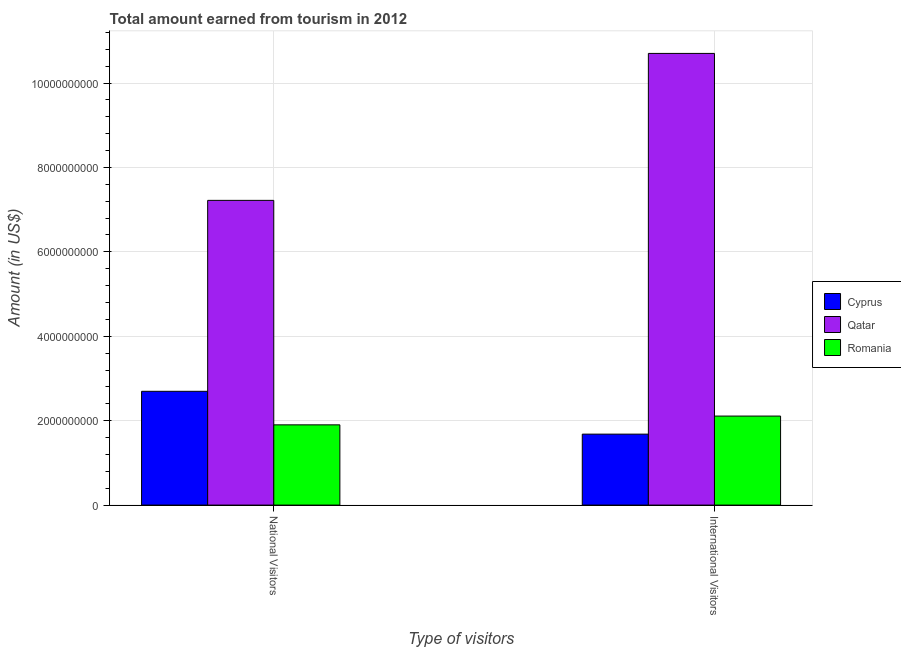How many groups of bars are there?
Your answer should be compact. 2. Are the number of bars on each tick of the X-axis equal?
Your response must be concise. Yes. How many bars are there on the 1st tick from the left?
Keep it short and to the point. 3. How many bars are there on the 2nd tick from the right?
Provide a short and direct response. 3. What is the label of the 1st group of bars from the left?
Give a very brief answer. National Visitors. What is the amount earned from international visitors in Qatar?
Offer a very short reply. 1.07e+1. Across all countries, what is the maximum amount earned from national visitors?
Give a very brief answer. 7.22e+09. Across all countries, what is the minimum amount earned from national visitors?
Your answer should be very brief. 1.90e+09. In which country was the amount earned from international visitors maximum?
Offer a very short reply. Qatar. In which country was the amount earned from national visitors minimum?
Offer a terse response. Romania. What is the total amount earned from national visitors in the graph?
Your response must be concise. 1.18e+1. What is the difference between the amount earned from national visitors in Cyprus and that in Qatar?
Provide a succinct answer. -4.52e+09. What is the difference between the amount earned from international visitors in Qatar and the amount earned from national visitors in Cyprus?
Your answer should be very brief. 8.01e+09. What is the average amount earned from international visitors per country?
Give a very brief answer. 4.83e+09. What is the difference between the amount earned from international visitors and amount earned from national visitors in Romania?
Provide a succinct answer. 2.08e+08. In how many countries, is the amount earned from international visitors greater than 8400000000 US$?
Keep it short and to the point. 1. What is the ratio of the amount earned from national visitors in Qatar to that in Romania?
Your answer should be compact. 3.8. Is the amount earned from international visitors in Romania less than that in Qatar?
Make the answer very short. Yes. In how many countries, is the amount earned from national visitors greater than the average amount earned from national visitors taken over all countries?
Make the answer very short. 1. What does the 1st bar from the left in International Visitors represents?
Offer a very short reply. Cyprus. What does the 3rd bar from the right in International Visitors represents?
Make the answer very short. Cyprus. How many bars are there?
Ensure brevity in your answer.  6. Are all the bars in the graph horizontal?
Give a very brief answer. No. How many countries are there in the graph?
Give a very brief answer. 3. Are the values on the major ticks of Y-axis written in scientific E-notation?
Your answer should be very brief. No. Does the graph contain any zero values?
Your response must be concise. No. Does the graph contain grids?
Your response must be concise. Yes. Where does the legend appear in the graph?
Keep it short and to the point. Center right. How are the legend labels stacked?
Keep it short and to the point. Vertical. What is the title of the graph?
Your answer should be compact. Total amount earned from tourism in 2012. What is the label or title of the X-axis?
Offer a terse response. Type of visitors. What is the label or title of the Y-axis?
Make the answer very short. Amount (in US$). What is the Amount (in US$) in Cyprus in National Visitors?
Your answer should be very brief. 2.70e+09. What is the Amount (in US$) in Qatar in National Visitors?
Your answer should be compact. 7.22e+09. What is the Amount (in US$) in Romania in National Visitors?
Provide a short and direct response. 1.90e+09. What is the Amount (in US$) in Cyprus in International Visitors?
Give a very brief answer. 1.68e+09. What is the Amount (in US$) of Qatar in International Visitors?
Your answer should be very brief. 1.07e+1. What is the Amount (in US$) of Romania in International Visitors?
Offer a very short reply. 2.11e+09. Across all Type of visitors, what is the maximum Amount (in US$) of Cyprus?
Give a very brief answer. 2.70e+09. Across all Type of visitors, what is the maximum Amount (in US$) in Qatar?
Give a very brief answer. 1.07e+1. Across all Type of visitors, what is the maximum Amount (in US$) of Romania?
Give a very brief answer. 2.11e+09. Across all Type of visitors, what is the minimum Amount (in US$) of Cyprus?
Provide a short and direct response. 1.68e+09. Across all Type of visitors, what is the minimum Amount (in US$) of Qatar?
Make the answer very short. 7.22e+09. Across all Type of visitors, what is the minimum Amount (in US$) of Romania?
Your answer should be compact. 1.90e+09. What is the total Amount (in US$) in Cyprus in the graph?
Offer a terse response. 4.38e+09. What is the total Amount (in US$) in Qatar in the graph?
Offer a terse response. 1.79e+1. What is the total Amount (in US$) of Romania in the graph?
Keep it short and to the point. 4.01e+09. What is the difference between the Amount (in US$) in Cyprus in National Visitors and that in International Visitors?
Give a very brief answer. 1.02e+09. What is the difference between the Amount (in US$) of Qatar in National Visitors and that in International Visitors?
Your response must be concise. -3.48e+09. What is the difference between the Amount (in US$) in Romania in National Visitors and that in International Visitors?
Provide a succinct answer. -2.08e+08. What is the difference between the Amount (in US$) of Cyprus in National Visitors and the Amount (in US$) of Qatar in International Visitors?
Provide a succinct answer. -8.01e+09. What is the difference between the Amount (in US$) of Cyprus in National Visitors and the Amount (in US$) of Romania in International Visitors?
Your answer should be very brief. 5.87e+08. What is the difference between the Amount (in US$) of Qatar in National Visitors and the Amount (in US$) of Romania in International Visitors?
Make the answer very short. 5.11e+09. What is the average Amount (in US$) of Cyprus per Type of visitors?
Provide a succinct answer. 2.19e+09. What is the average Amount (in US$) in Qatar per Type of visitors?
Offer a very short reply. 8.96e+09. What is the average Amount (in US$) of Romania per Type of visitors?
Give a very brief answer. 2.00e+09. What is the difference between the Amount (in US$) in Cyprus and Amount (in US$) in Qatar in National Visitors?
Give a very brief answer. -4.52e+09. What is the difference between the Amount (in US$) in Cyprus and Amount (in US$) in Romania in National Visitors?
Make the answer very short. 7.95e+08. What is the difference between the Amount (in US$) in Qatar and Amount (in US$) in Romania in National Visitors?
Ensure brevity in your answer.  5.32e+09. What is the difference between the Amount (in US$) of Cyprus and Amount (in US$) of Qatar in International Visitors?
Your answer should be compact. -9.02e+09. What is the difference between the Amount (in US$) in Cyprus and Amount (in US$) in Romania in International Visitors?
Offer a terse response. -4.28e+08. What is the difference between the Amount (in US$) in Qatar and Amount (in US$) in Romania in International Visitors?
Offer a terse response. 8.59e+09. What is the ratio of the Amount (in US$) in Cyprus in National Visitors to that in International Visitors?
Provide a succinct answer. 1.6. What is the ratio of the Amount (in US$) of Qatar in National Visitors to that in International Visitors?
Provide a short and direct response. 0.67. What is the ratio of the Amount (in US$) in Romania in National Visitors to that in International Visitors?
Your response must be concise. 0.9. What is the difference between the highest and the second highest Amount (in US$) of Cyprus?
Ensure brevity in your answer.  1.02e+09. What is the difference between the highest and the second highest Amount (in US$) of Qatar?
Provide a succinct answer. 3.48e+09. What is the difference between the highest and the second highest Amount (in US$) of Romania?
Keep it short and to the point. 2.08e+08. What is the difference between the highest and the lowest Amount (in US$) in Cyprus?
Offer a terse response. 1.02e+09. What is the difference between the highest and the lowest Amount (in US$) in Qatar?
Provide a succinct answer. 3.48e+09. What is the difference between the highest and the lowest Amount (in US$) in Romania?
Provide a succinct answer. 2.08e+08. 